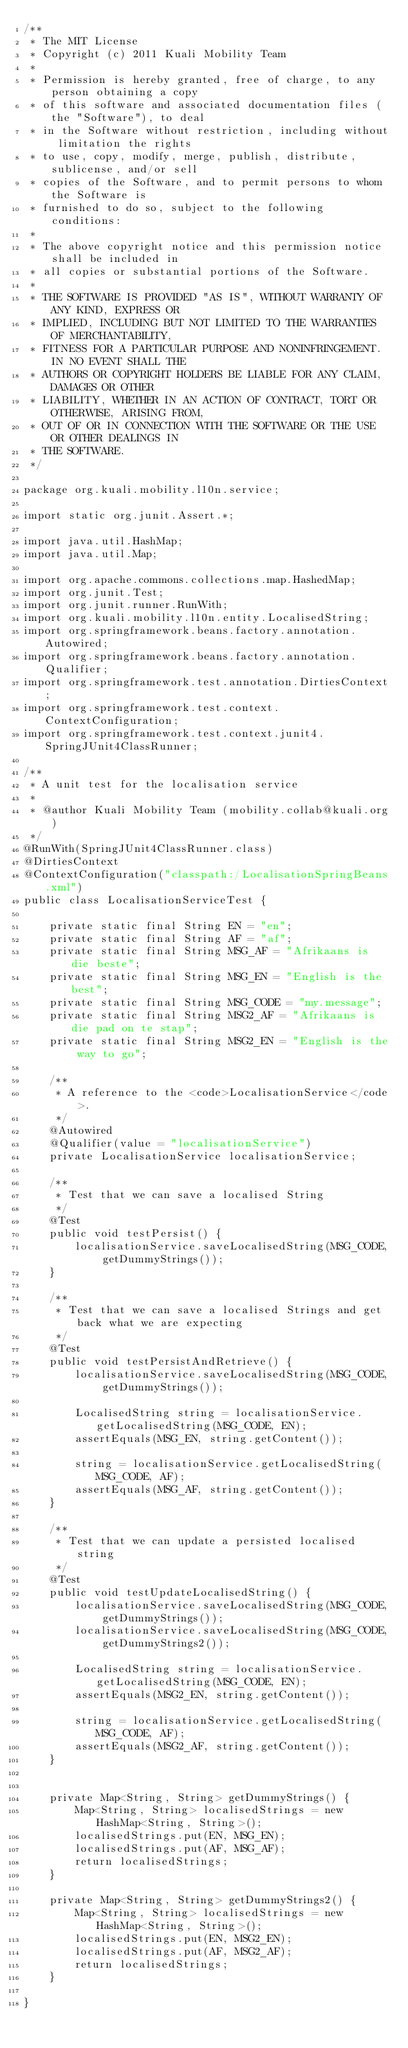<code> <loc_0><loc_0><loc_500><loc_500><_Java_>/**
 * The MIT License
 * Copyright (c) 2011 Kuali Mobility Team
 *
 * Permission is hereby granted, free of charge, to any person obtaining a copy
 * of this software and associated documentation files (the "Software"), to deal
 * in the Software without restriction, including without limitation the rights
 * to use, copy, modify, merge, publish, distribute, sublicense, and/or sell
 * copies of the Software, and to permit persons to whom the Software is
 * furnished to do so, subject to the following conditions:
 *
 * The above copyright notice and this permission notice shall be included in
 * all copies or substantial portions of the Software.
 *
 * THE SOFTWARE IS PROVIDED "AS IS", WITHOUT WARRANTY OF ANY KIND, EXPRESS OR
 * IMPLIED, INCLUDING BUT NOT LIMITED TO THE WARRANTIES OF MERCHANTABILITY,
 * FITNESS FOR A PARTICULAR PURPOSE AND NONINFRINGEMENT. IN NO EVENT SHALL THE
 * AUTHORS OR COPYRIGHT HOLDERS BE LIABLE FOR ANY CLAIM, DAMAGES OR OTHER
 * LIABILITY, WHETHER IN AN ACTION OF CONTRACT, TORT OR OTHERWISE, ARISING FROM,
 * OUT OF OR IN CONNECTION WITH THE SOFTWARE OR THE USE OR OTHER DEALINGS IN
 * THE SOFTWARE.
 */

package org.kuali.mobility.l10n.service;

import static org.junit.Assert.*;

import java.util.HashMap;
import java.util.Map;

import org.apache.commons.collections.map.HashedMap;
import org.junit.Test;
import org.junit.runner.RunWith;
import org.kuali.mobility.l10n.entity.LocalisedString;
import org.springframework.beans.factory.annotation.Autowired;
import org.springframework.beans.factory.annotation.Qualifier;
import org.springframework.test.annotation.DirtiesContext;
import org.springframework.test.context.ContextConfiguration;
import org.springframework.test.context.junit4.SpringJUnit4ClassRunner;

/**
 * A unit test for the localisation service
 *
 * @author Kuali Mobility Team (mobility.collab@kuali.org)
 */
@RunWith(SpringJUnit4ClassRunner.class)
@DirtiesContext
@ContextConfiguration("classpath:/LocalisationSpringBeans.xml")
public class LocalisationServiceTest {

	private static final String EN = "en";
	private static final String AF = "af";
	private static final String MSG_AF = "Afrikaans is die beste";
	private static final String MSG_EN = "English is the best";
	private static final String MSG_CODE = "my.message";
	private static final String MSG2_AF = "Afrikaans is die pad on te stap";
	private static final String MSG2_EN = "English is the way to go";

	/**
	 * A reference to the <code>LocalisationService</code>.
	 */
	@Autowired
	@Qualifier(value = "localisationService")
	private LocalisationService localisationService;

	/**
	 * Test that we can save a localised String
	 */
	@Test
	public void testPersist() {
		localisationService.saveLocalisedString(MSG_CODE, getDummyStrings());
	}

	/**
	 * Test that we can save a localised Strings and get back what we are expecting
	 */
	@Test
	public void testPersistAndRetrieve() {
		localisationService.saveLocalisedString(MSG_CODE, getDummyStrings());

		LocalisedString string = localisationService.getLocalisedString(MSG_CODE, EN);
		assertEquals(MSG_EN, string.getContent());

		string = localisationService.getLocalisedString(MSG_CODE, AF);
		assertEquals(MSG_AF, string.getContent());
	}

	/**
	 * Test that we can update a persisted localised string
	 */
	@Test
	public void testUpdateLocalisedString() {
		localisationService.saveLocalisedString(MSG_CODE, getDummyStrings());
		localisationService.saveLocalisedString(MSG_CODE, getDummyStrings2());

		LocalisedString string = localisationService.getLocalisedString(MSG_CODE, EN);
		assertEquals(MSG2_EN, string.getContent());

		string = localisationService.getLocalisedString(MSG_CODE, AF);
		assertEquals(MSG2_AF, string.getContent());
	}


	private Map<String, String> getDummyStrings() {
		Map<String, String> localisedStrings = new HashMap<String, String>();
		localisedStrings.put(EN, MSG_EN);
		localisedStrings.put(AF, MSG_AF);
		return localisedStrings;
	}

	private Map<String, String> getDummyStrings2() {
		Map<String, String> localisedStrings = new HashMap<String, String>();
		localisedStrings.put(EN, MSG2_EN);
		localisedStrings.put(AF, MSG2_AF);
		return localisedStrings;
	}

}
</code> 